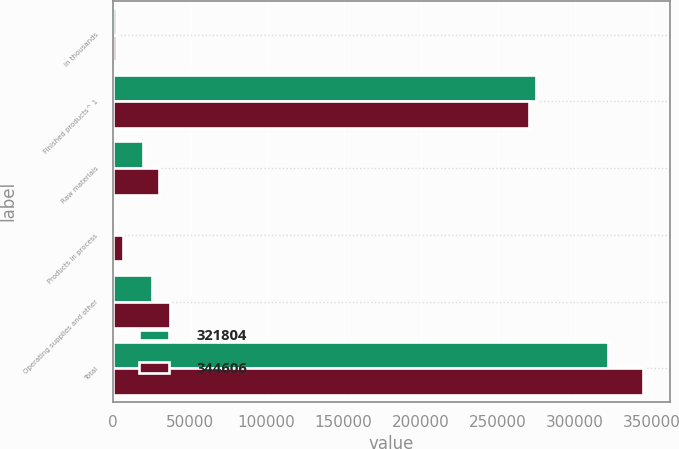Convert chart to OTSL. <chart><loc_0><loc_0><loc_500><loc_500><stacked_bar_chart><ecel><fcel>in thousands<fcel>Finished products^ 1<fcel>Raw materials<fcel>Products in process<fcel>Operating supplies and other<fcel>Total<nl><fcel>321804<fcel>2014<fcel>275172<fcel>19741<fcel>1250<fcel>25641<fcel>321804<nl><fcel>344606<fcel>2013<fcel>270603<fcel>29996<fcel>6613<fcel>37394<fcel>344606<nl></chart> 